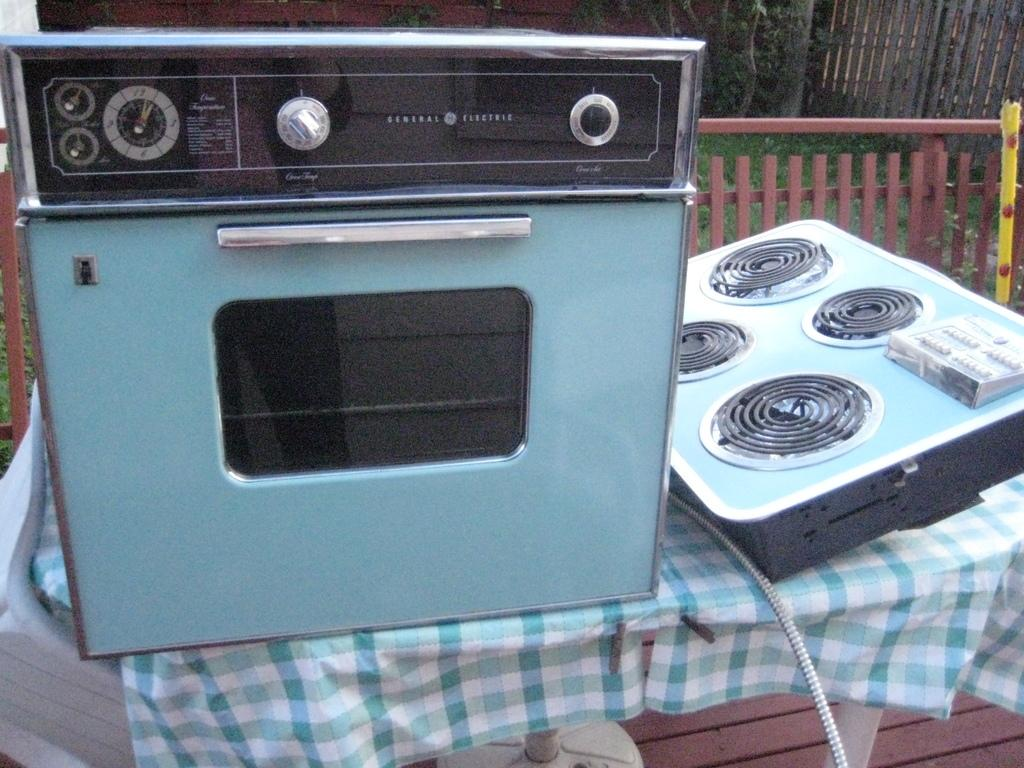<image>
Write a terse but informative summary of the picture. A General Electric oven and stove top sit on a table. 